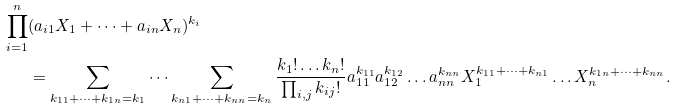Convert formula to latex. <formula><loc_0><loc_0><loc_500><loc_500>\prod _ { i = 1 } ^ { n } & ( a _ { i 1 } X _ { 1 } + \dots + a _ { i n } X _ { n } ) ^ { k _ { i } } \\ & = \sum _ { k _ { 1 1 } + \dots + k _ { 1 n } = k _ { 1 } } \dots \sum _ { k _ { n 1 } + \dots + k _ { n n } = k _ { n } } \frac { k _ { 1 } ! \dots k _ { n } ! } { \prod _ { i , j } k _ { i j } ! } a _ { 1 1 } ^ { k _ { 1 1 } } a _ { 1 2 } ^ { k _ { 1 2 } } \dots a _ { n n } ^ { k _ { n n } } X _ { 1 } ^ { k _ { 1 1 } + \dots + k _ { n 1 } } \dots X _ { n } ^ { k _ { 1 n } + \dots + k _ { n n } } .</formula> 